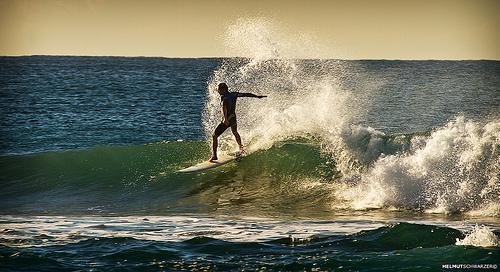How many people are in the picture?
Give a very brief answer. 1. 